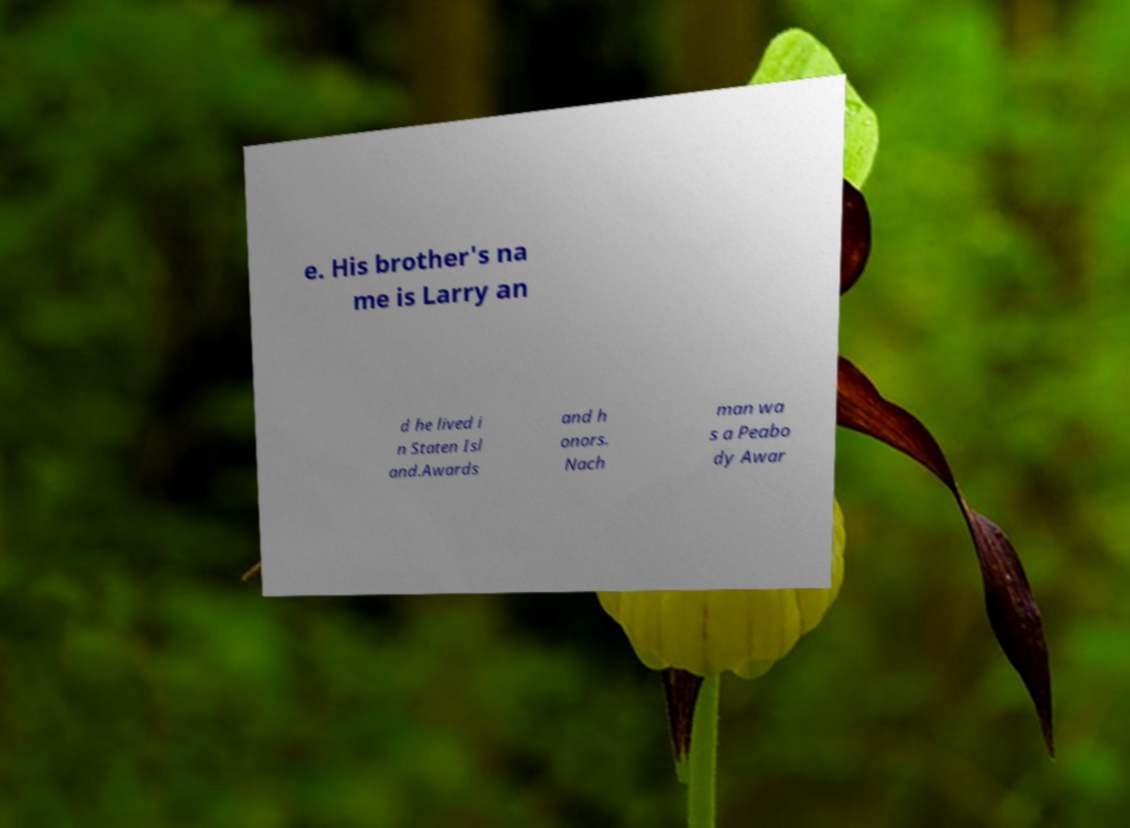There's text embedded in this image that I need extracted. Can you transcribe it verbatim? e. His brother's na me is Larry an d he lived i n Staten Isl and.Awards and h onors. Nach man wa s a Peabo dy Awar 